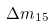<formula> <loc_0><loc_0><loc_500><loc_500>\Delta { m } _ { 1 5 }</formula> 